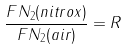Convert formula to latex. <formula><loc_0><loc_0><loc_500><loc_500>\frac { F N _ { 2 } ( n i t r o x ) } { F N _ { 2 } ( a i r ) } = R</formula> 